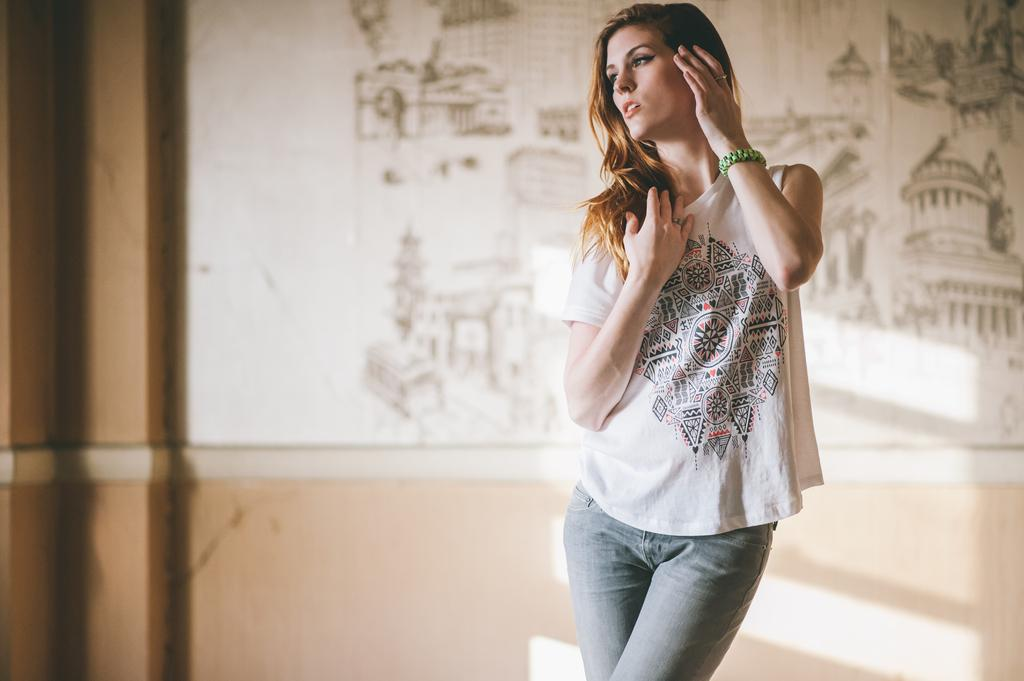Who is the main subject in the picture? There is a woman in the picture. What is the woman wearing? The woman is wearing a white T-shirt. What is the woman doing in the picture? The woman is posing for a photo. What can be seen in the background of the picture? There is a sketch of buildings and a white wall in the background. What is the reaction of the family members in the picture? There is no family present in the image, so it is not possible to determine their reactions. 